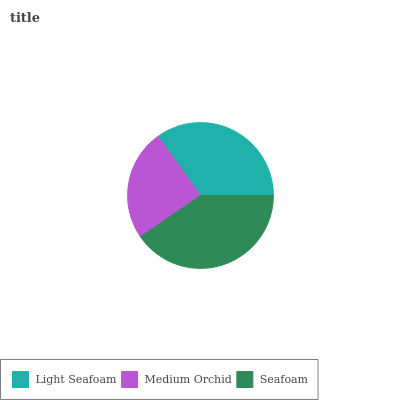Is Medium Orchid the minimum?
Answer yes or no. Yes. Is Seafoam the maximum?
Answer yes or no. Yes. Is Seafoam the minimum?
Answer yes or no. No. Is Medium Orchid the maximum?
Answer yes or no. No. Is Seafoam greater than Medium Orchid?
Answer yes or no. Yes. Is Medium Orchid less than Seafoam?
Answer yes or no. Yes. Is Medium Orchid greater than Seafoam?
Answer yes or no. No. Is Seafoam less than Medium Orchid?
Answer yes or no. No. Is Light Seafoam the high median?
Answer yes or no. Yes. Is Light Seafoam the low median?
Answer yes or no. Yes. Is Medium Orchid the high median?
Answer yes or no. No. Is Medium Orchid the low median?
Answer yes or no. No. 